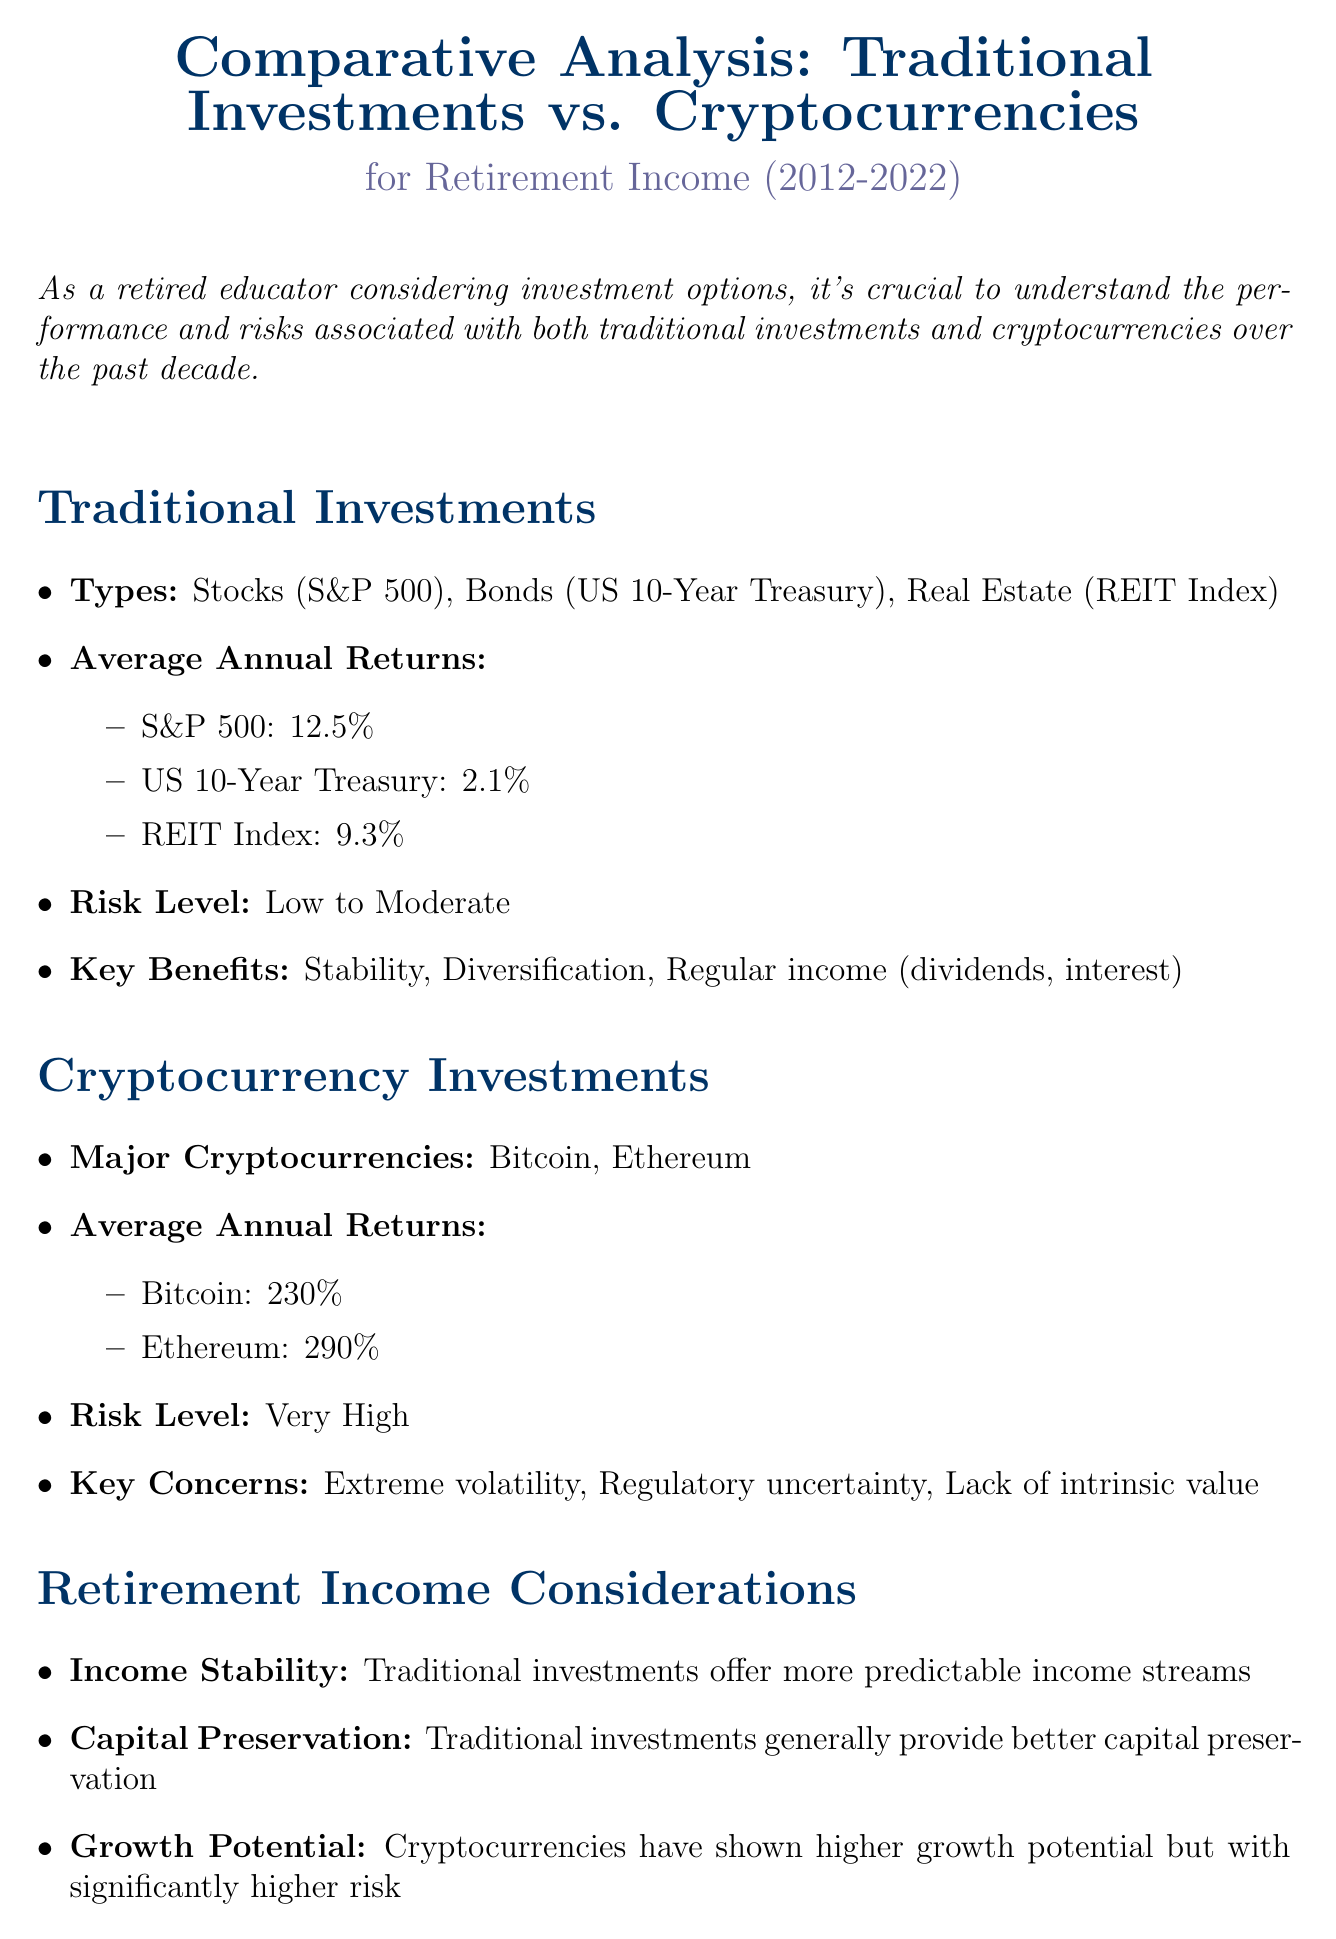What is the average annual return of Bitcoin? The average annual return of Bitcoin is specified as 230% in the document.
Answer: 230% What is the risk level associated with traditional investments? The document mentions that the risk level for traditional investments is classified as low to moderate.
Answer: Low to Moderate What is a key benefit of traditional investments? The document lists stability, diversification, and regular income as key benefits of traditional investments.
Answer: Stability Which cryptocurrencies are mentioned in the document? The document provides the names of the major cryptocurrencies as Bitcoin and Ethereum.
Answer: Bitcoin, Ethereum What is the average annual return of the S&P 500? The average annual return of the S&P 500 is stated as 12.5% in the document.
Answer: 12.5% What aspect of income do traditional investments provide? The document notes that traditional investments offer more predictable income streams, emphasizing income stability.
Answer: Predictable income streams What is the expert’s recommendation regarding cryptocurrency for retirement savings? According to the expert opinion, a conservative approach focusing on traditional investments is generally recommended for retirement savings.
Answer: Conservative approach What is one key concern associated with cryptocurrencies? The document highlights extreme volatility, regulatory uncertainty, and lack of intrinsic value as key concerns regarding cryptocurrencies.
Answer: Extreme volatility What is the conclusion regarding investment recommendations for a retired teacher? The conclusion suggests that a portfolio heavily weighted towards traditional investments may be more suitable for a retired teacher.
Answer: Heavily weighted towards traditional investments 